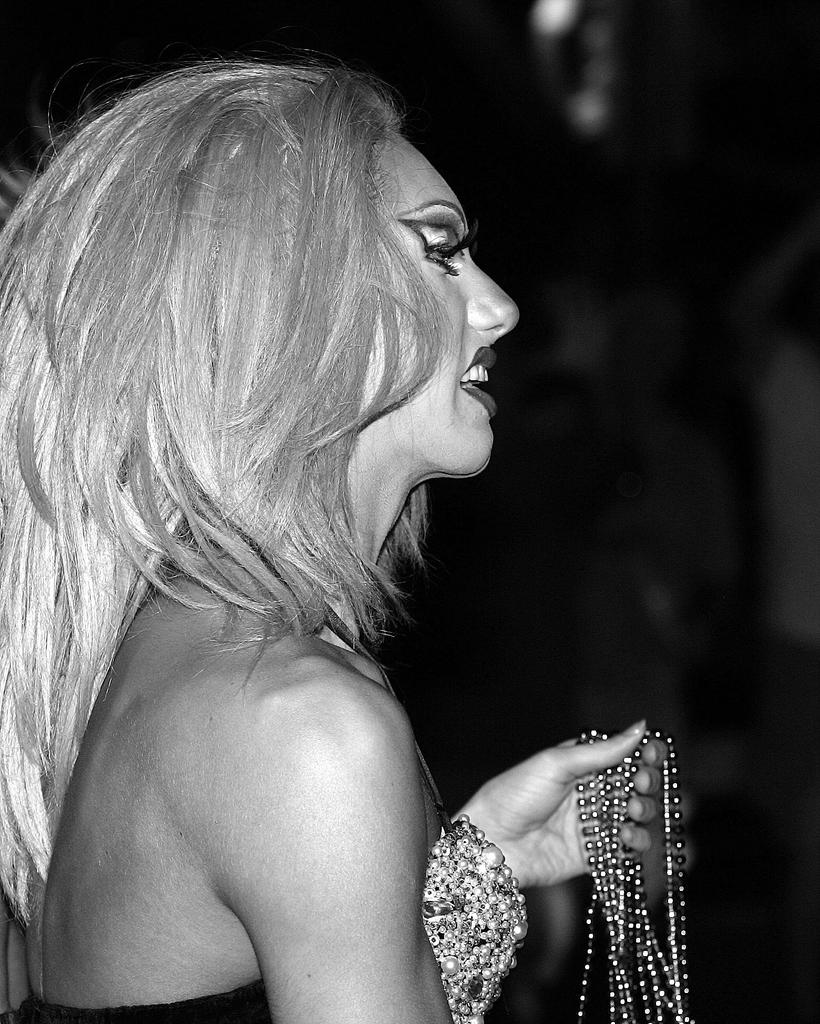What is present in the image? There is a person in the image. Can you describe the person's attire? The person is wearing clothes. What is the person holding in the image? The person is holding a pearls necklace with her hand. What type of milk is being poured from the roof in the image? There is no milk or roof present in the image. 